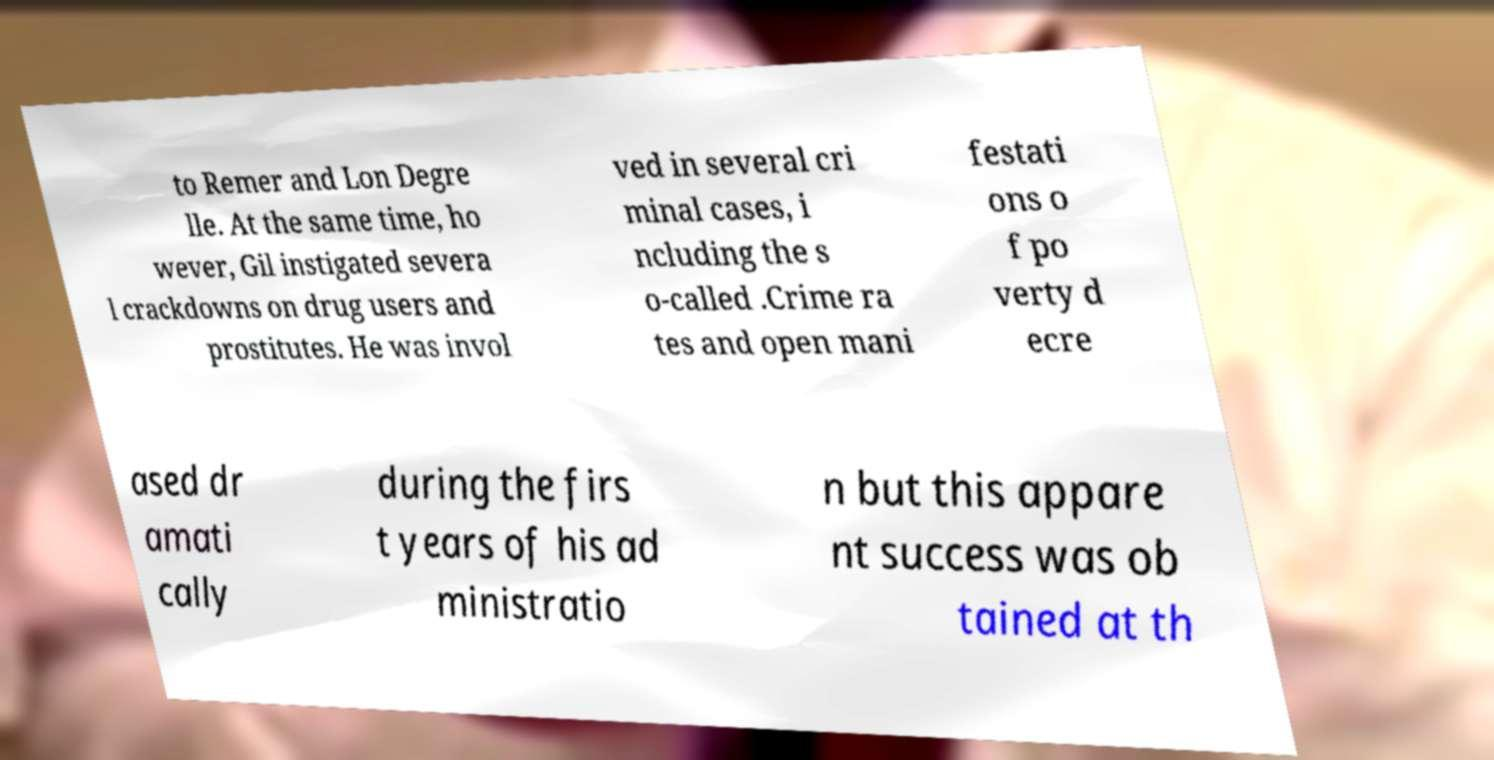Can you read and provide the text displayed in the image?This photo seems to have some interesting text. Can you extract and type it out for me? to Remer and Lon Degre lle. At the same time, ho wever, Gil instigated severa l crackdowns on drug users and prostitutes. He was invol ved in several cri minal cases, i ncluding the s o-called .Crime ra tes and open mani festati ons o f po verty d ecre ased dr amati cally during the firs t years of his ad ministratio n but this appare nt success was ob tained at th 